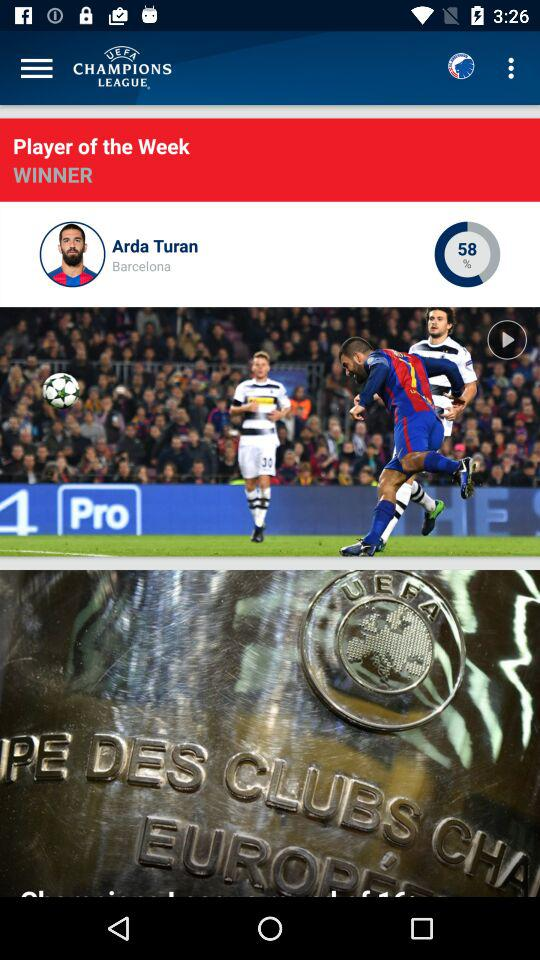What is the name of the player of the week? The player of the week is Arda Turan. 